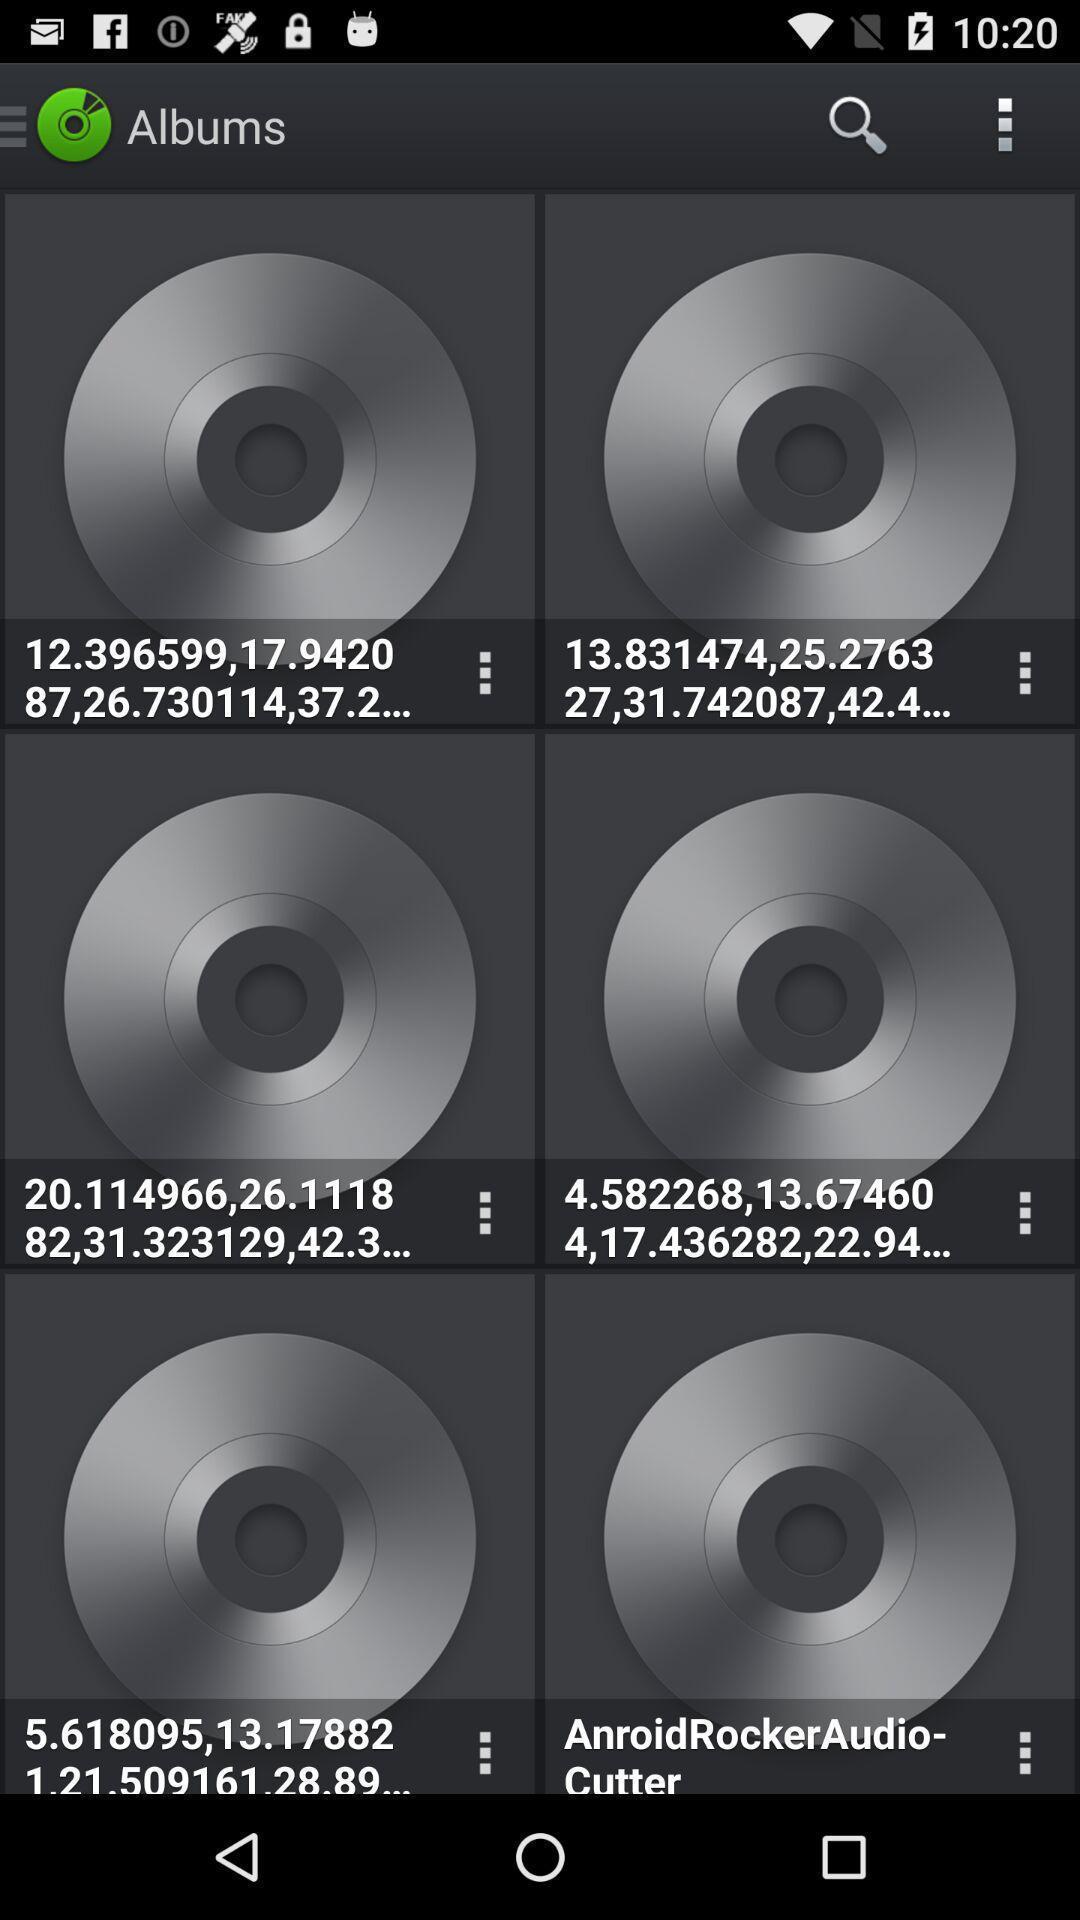Provide a description of this screenshot. Page that displaying music player application. 